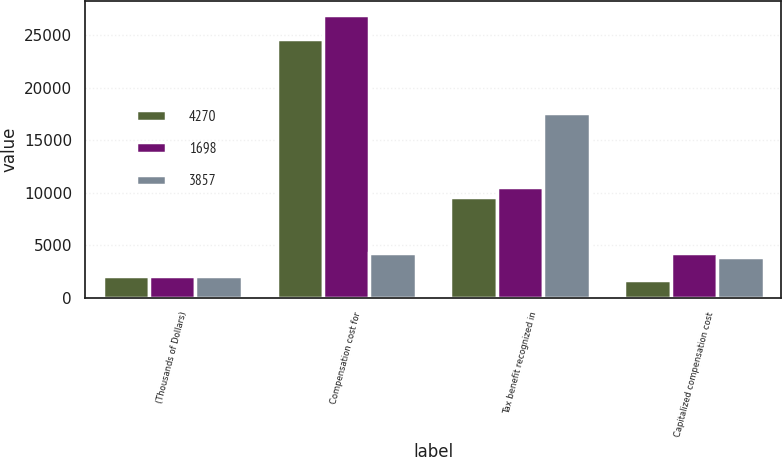<chart> <loc_0><loc_0><loc_500><loc_500><stacked_bar_chart><ecel><fcel>(Thousands of Dollars)<fcel>Compensation cost for<fcel>Tax benefit recognized in<fcel>Capitalized compensation cost<nl><fcel>4270<fcel>2013<fcel>24613<fcel>9571<fcel>1698<nl><fcel>1698<fcel>2012<fcel>26970<fcel>10513<fcel>4270<nl><fcel>3857<fcel>2011<fcel>4270<fcel>17559<fcel>3857<nl></chart> 